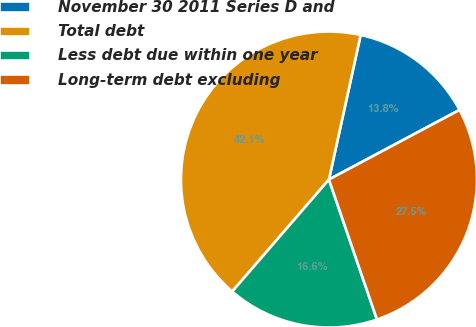<chart> <loc_0><loc_0><loc_500><loc_500><pie_chart><fcel>November 30 2011 Series D and<fcel>Total debt<fcel>Less debt due within one year<fcel>Long-term debt excluding<nl><fcel>13.77%<fcel>42.1%<fcel>16.6%<fcel>27.53%<nl></chart> 